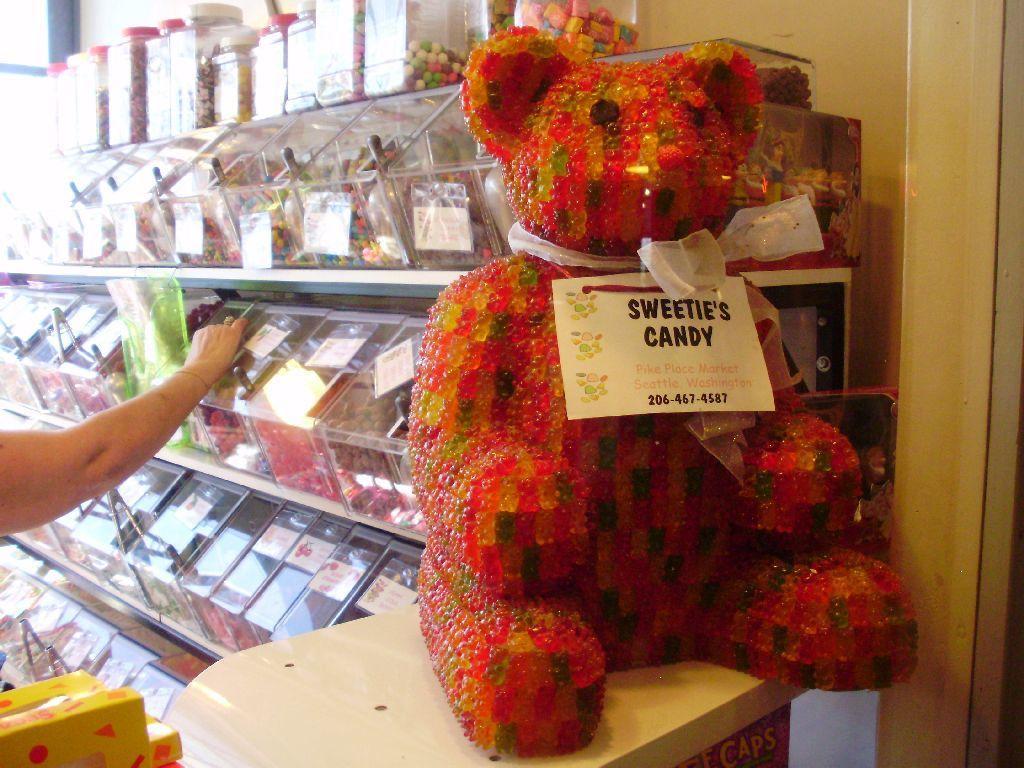Could you give a brief overview of what you see in this image? In this picture we can see a board on a toy. This toy is on the table. We can see a person holding an object. There are a few boxes on the left side. We can see some bottles and food items in the boxes. These boxes are arranged on the shelves. 